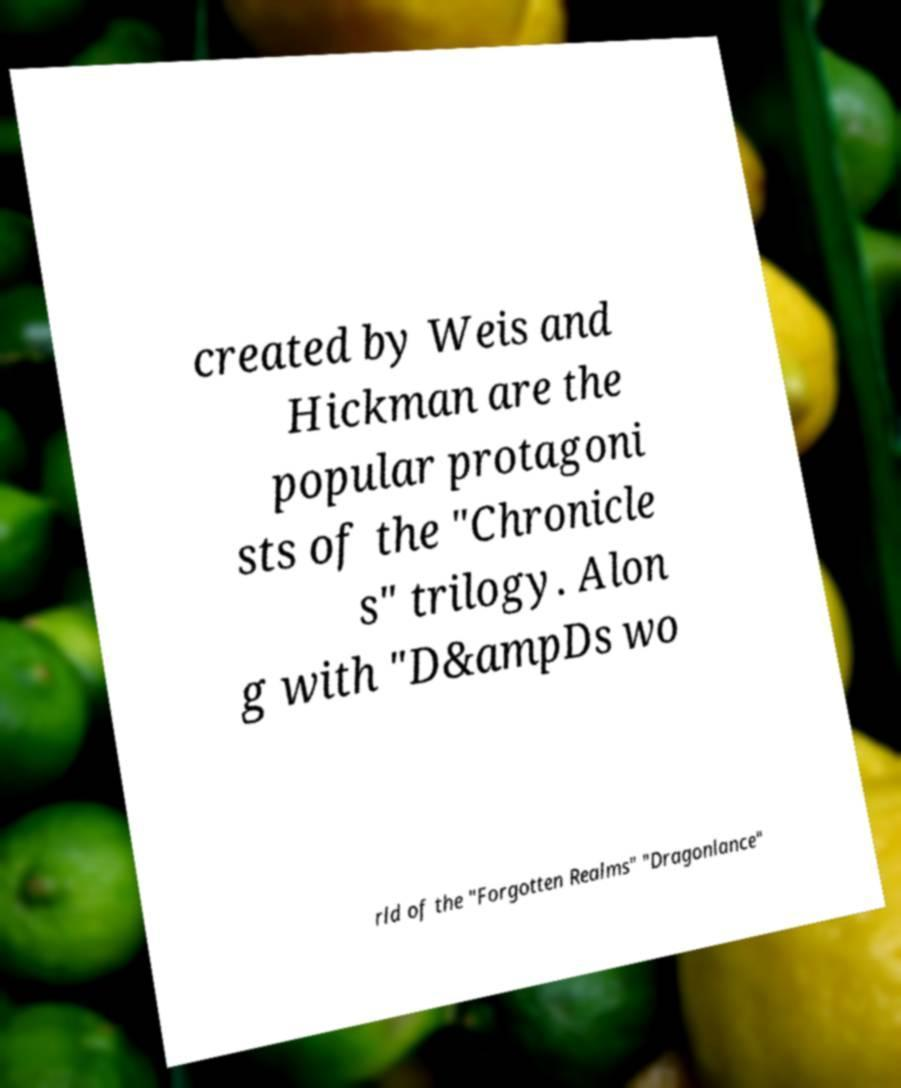For documentation purposes, I need the text within this image transcribed. Could you provide that? created by Weis and Hickman are the popular protagoni sts of the "Chronicle s" trilogy. Alon g with "D&ampDs wo rld of the "Forgotten Realms" "Dragonlance" 